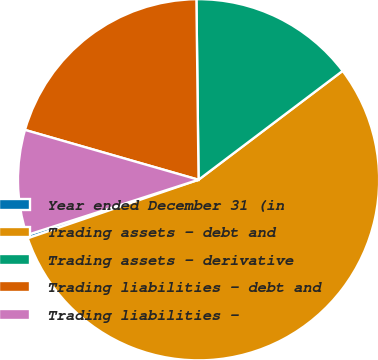Convert chart to OTSL. <chart><loc_0><loc_0><loc_500><loc_500><pie_chart><fcel>Year ended December 31 (in<fcel>Trading assets - debt and<fcel>Trading assets - derivative<fcel>Trading liabilities - debt and<fcel>Trading liabilities -<nl><fcel>0.29%<fcel>55.05%<fcel>14.89%<fcel>20.36%<fcel>9.41%<nl></chart> 